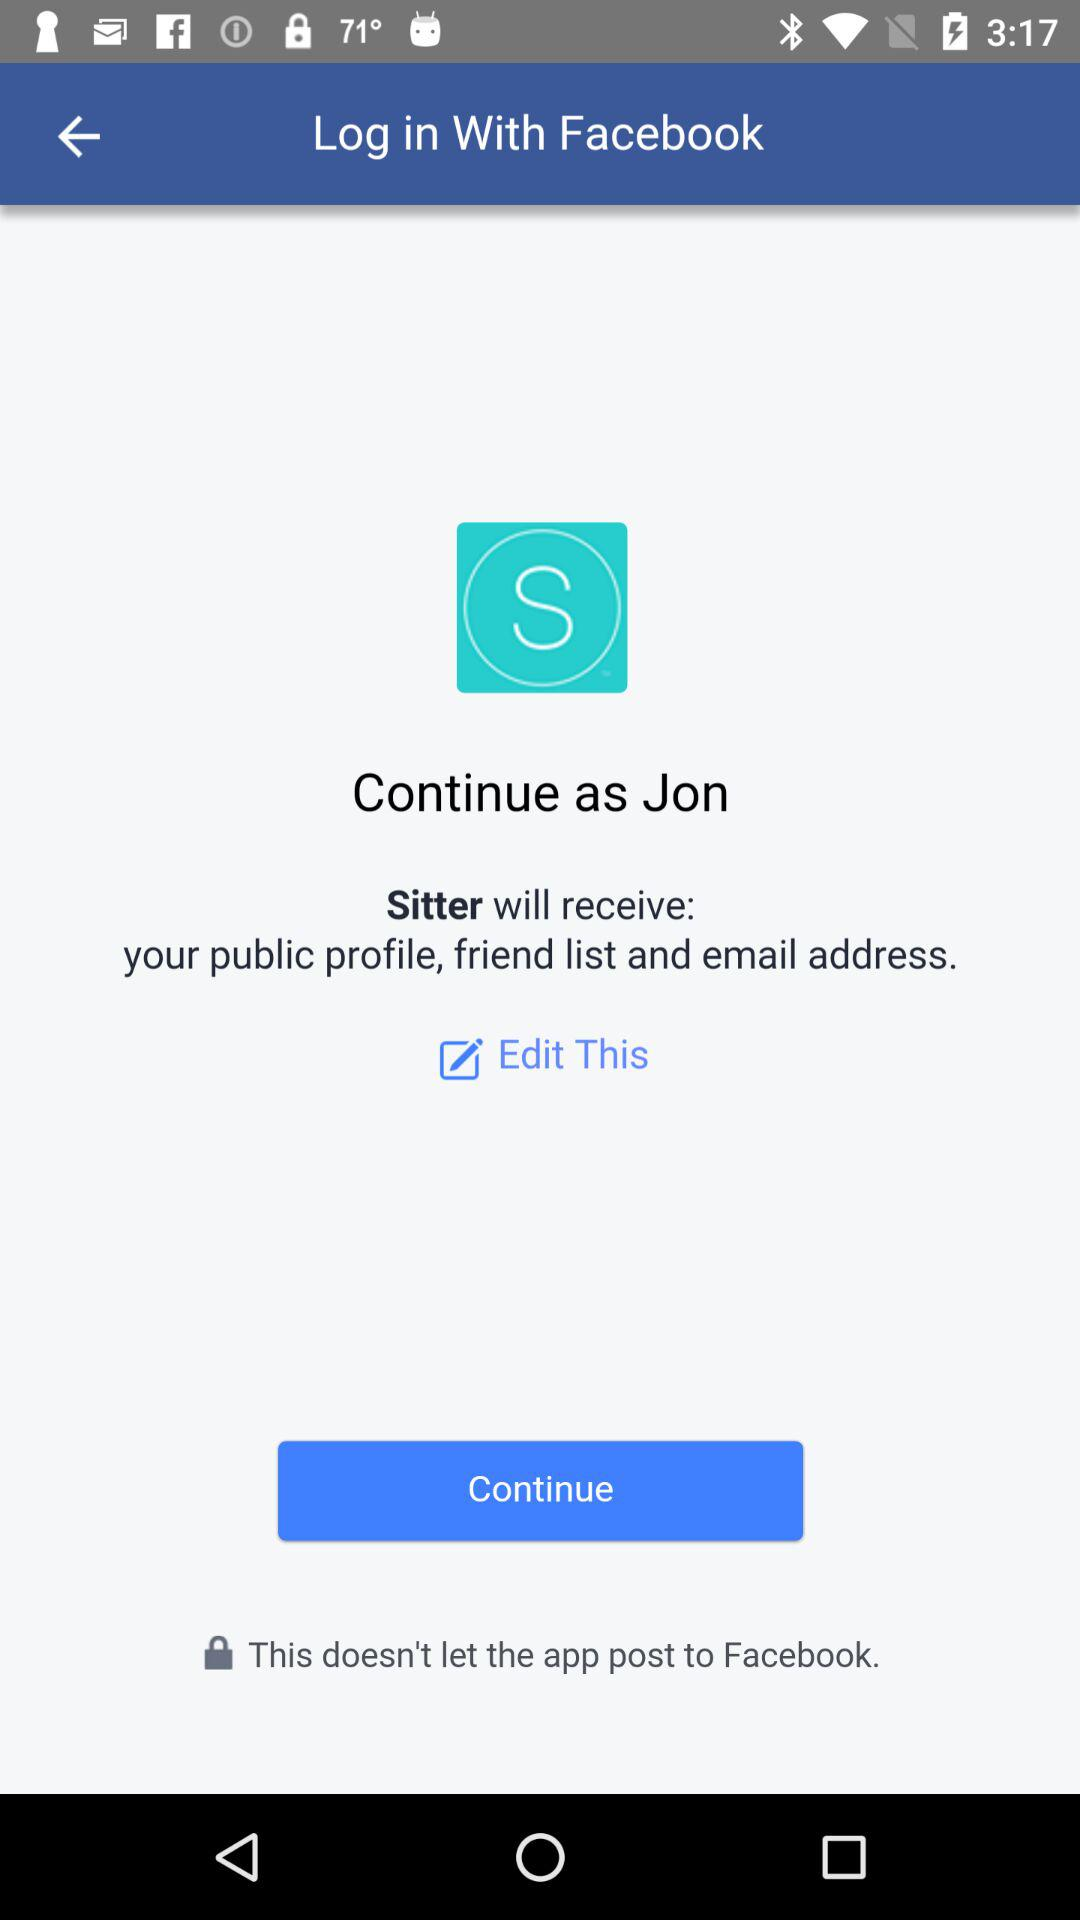Who will receive the public profile, friend list and email address? The public profile, friend list and email address will be received by "Sitter". 